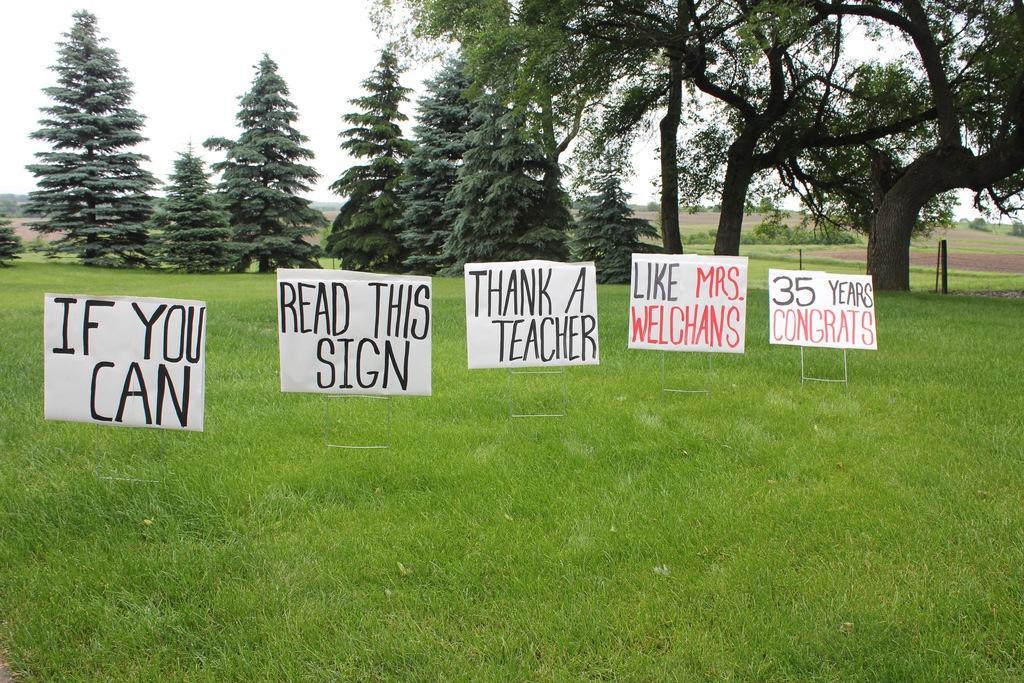Please provide a concise description of this image. In this image I can see grass ground, few white colour boards, number of trees and on these boards I can see something is written. 